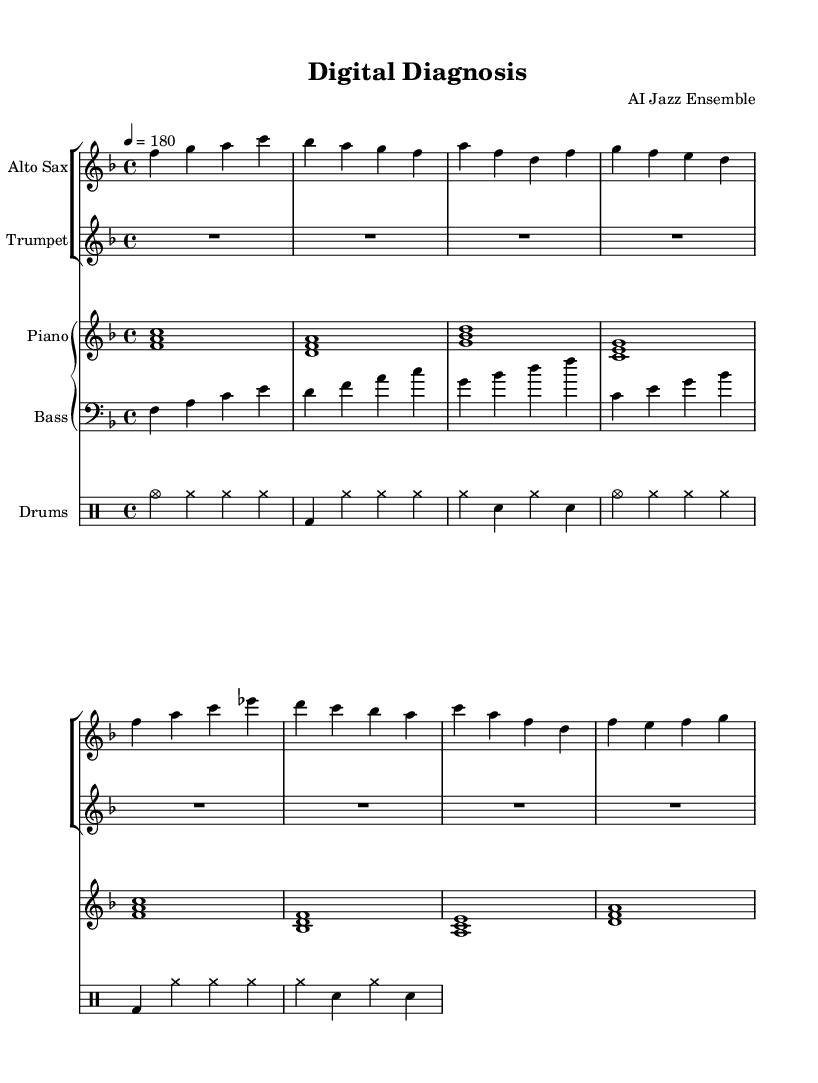What is the title of this piece? The title is prominently displayed in the header section of the score, which states "Digital Diagnosis."
Answer: Digital Diagnosis What is the key signature of this music? By examining the key signature indicated in the global music settings, which shows there is one flat (B), it is F major.
Answer: F major What is the time signature of this music? The time signature is specified in the global settings as 4/4, which means there are four beats per measure.
Answer: 4/4 What is the tempo marking for this piece? The tempo is indicated in the global settings as "4 = 180," meaning there are 180 quarter note beats per minute.
Answer: 180 How many instruments are featured in this score? By counting the distinct parts listed in the score, there are four: Alto Sax, Trumpet, Piano, Bass, and Drums. Thus, a total of five instruments are featured.
Answer: Five instruments Which instrument plays the longest note value in the first measure? In the first measure of the piano staff, it shows a whole note chord, which represents the longest note value compared to the other instruments that play shorter notes or rests.
Answer: Piano What is the role of the drums in this jazz piece? The drum part primarily serves to keep rhythm with a standard jazz drum pattern, incorporating elements like cymbals and bass drum for a steady swing feel typical in jazz music.
Answer: Rhythm section 